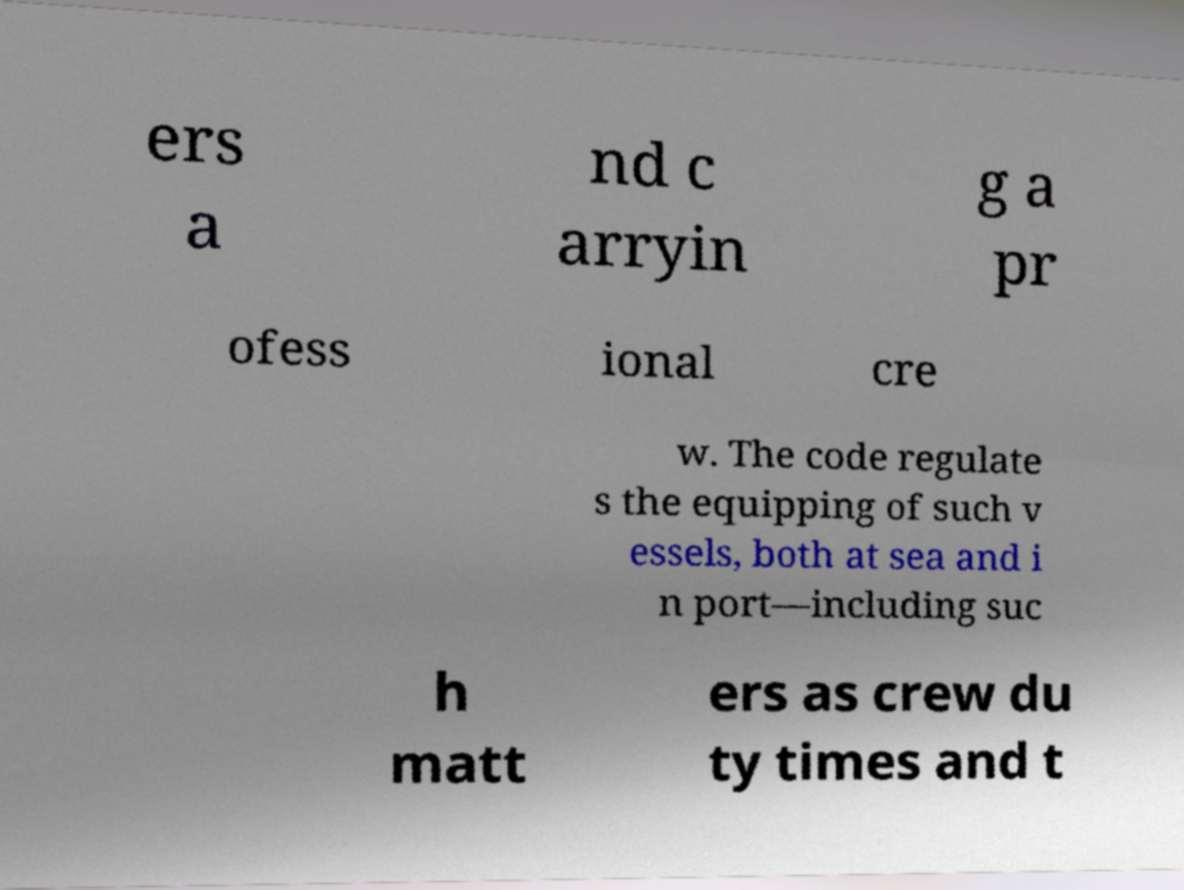Can you read and provide the text displayed in the image?This photo seems to have some interesting text. Can you extract and type it out for me? ers a nd c arryin g a pr ofess ional cre w. The code regulate s the equipping of such v essels, both at sea and i n port—including suc h matt ers as crew du ty times and t 